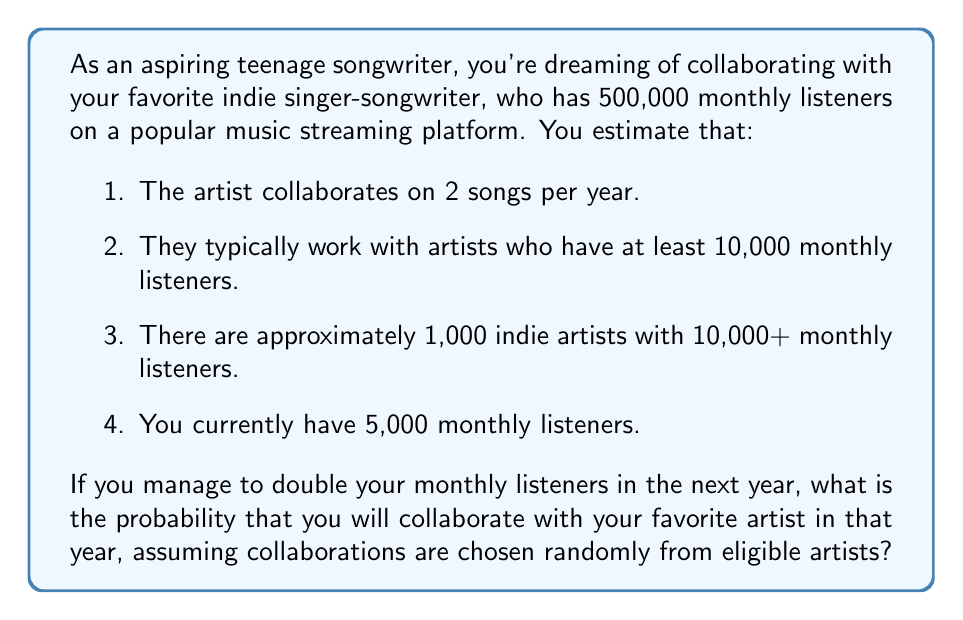Can you answer this question? Let's approach this step-by-step:

1. First, we need to determine if you'll be eligible for collaboration:
   - Currently, you have 5,000 monthly listeners
   - If you double this, you'll have 10,000 monthly listeners
   - This means you'll just reach the threshold for eligibility

2. Now, let's calculate the total number of eligible artists:
   - There are 1,000 indie artists with 10,000+ monthly listeners
   - You will also be eligible, so the total is 1,001

3. The artist collaborates on 2 songs per year. This means there are 2 opportunities for collaboration.

4. The probability of being chosen for one collaboration is:
   $$ P(\text{chosen for one collaboration}) = \frac{1}{1001} $$

5. The probability of not being chosen for one collaboration is:
   $$ P(\text{not chosen for one collaboration}) = 1 - \frac{1}{1001} = \frac{1000}{1001} $$

6. For two collaborations, we need to calculate the probability of not being chosen twice and then subtract this from 1:

   $$ P(\text{chosen for at least one collaboration}) = 1 - P(\text{not chosen for either collaboration}) $$
   $$ = 1 - \left(\frac{1000}{1001}\right)^2 $$
   $$ = 1 - \frac{1000000}{1002001} $$
   $$ = \frac{1002001 - 1000000}{1002001} $$
   $$ = \frac{2001}{1002001} $$
   $$ \approx 0.001996 $$
Answer: The probability of collaborating with your favorite artist in the next year, assuming you double your monthly listeners, is approximately 0.001996 or about 0.1996%. 